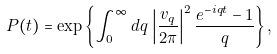<formula> <loc_0><loc_0><loc_500><loc_500>P ( t ) = \exp \left \{ \int _ { 0 } ^ { \infty } d q \, \left | \frac { v _ { q } } { 2 \pi } \right | ^ { 2 } \frac { e ^ { - i q t } - 1 } { q } \right \} ,</formula> 